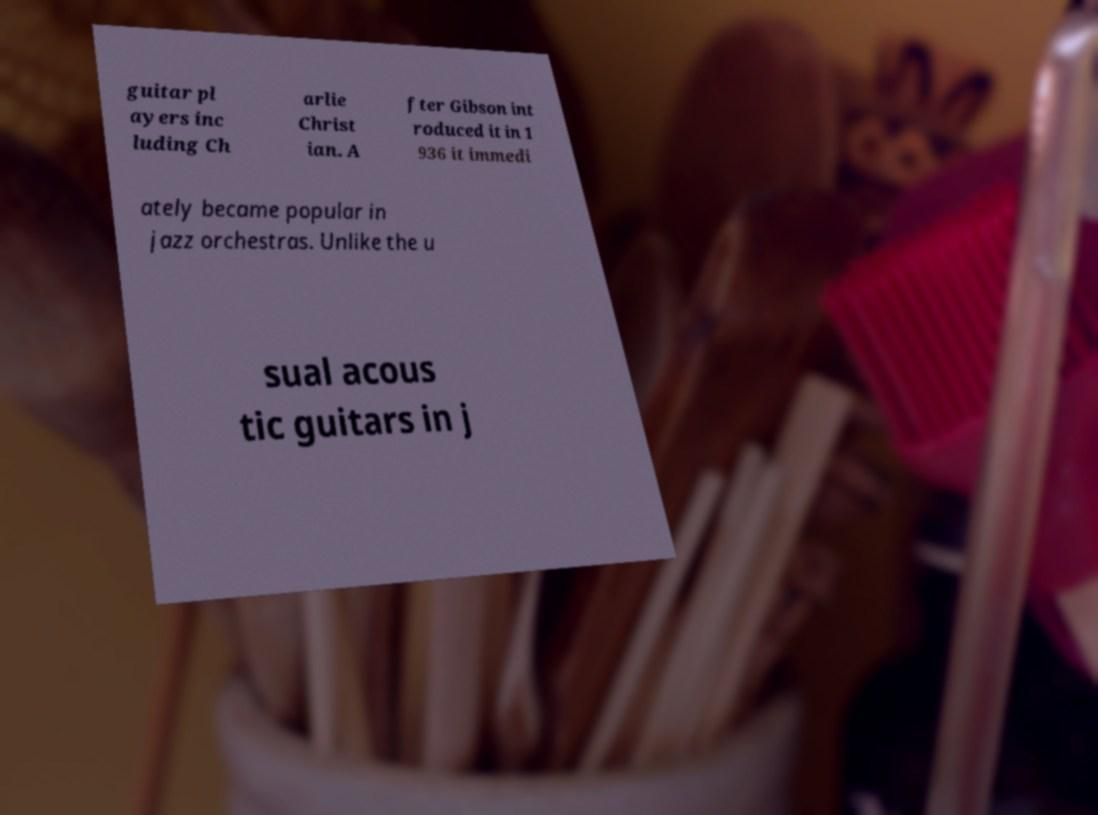Can you read and provide the text displayed in the image?This photo seems to have some interesting text. Can you extract and type it out for me? guitar pl ayers inc luding Ch arlie Christ ian. A fter Gibson int roduced it in 1 936 it immedi ately became popular in jazz orchestras. Unlike the u sual acous tic guitars in j 